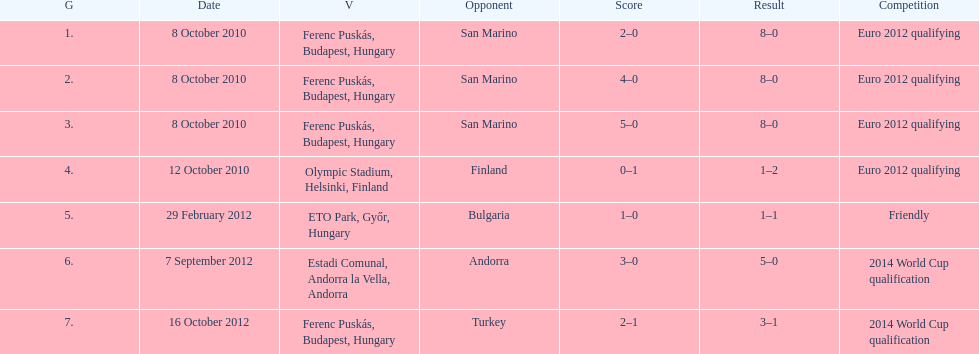What is the number of goals ádám szalai made against san marino in 2010? 3. Help me parse the entirety of this table. {'header': ['G', 'Date', 'V', 'Opponent', 'Score', 'Result', 'Competition'], 'rows': [['1.', '8 October 2010', 'Ferenc Puskás, Budapest, Hungary', 'San Marino', '2–0', '8–0', 'Euro 2012 qualifying'], ['2.', '8 October 2010', 'Ferenc Puskás, Budapest, Hungary', 'San Marino', '4–0', '8–0', 'Euro 2012 qualifying'], ['3.', '8 October 2010', 'Ferenc Puskás, Budapest, Hungary', 'San Marino', '5–0', '8–0', 'Euro 2012 qualifying'], ['4.', '12 October 2010', 'Olympic Stadium, Helsinki, Finland', 'Finland', '0–1', '1–2', 'Euro 2012 qualifying'], ['5.', '29 February 2012', 'ETO Park, Győr, Hungary', 'Bulgaria', '1–0', '1–1', 'Friendly'], ['6.', '7 September 2012', 'Estadi Comunal, Andorra la Vella, Andorra', 'Andorra', '3–0', '5–0', '2014 World Cup qualification'], ['7.', '16 October 2012', 'Ferenc Puskás, Budapest, Hungary', 'Turkey', '2–1', '3–1', '2014 World Cup qualification']]} 